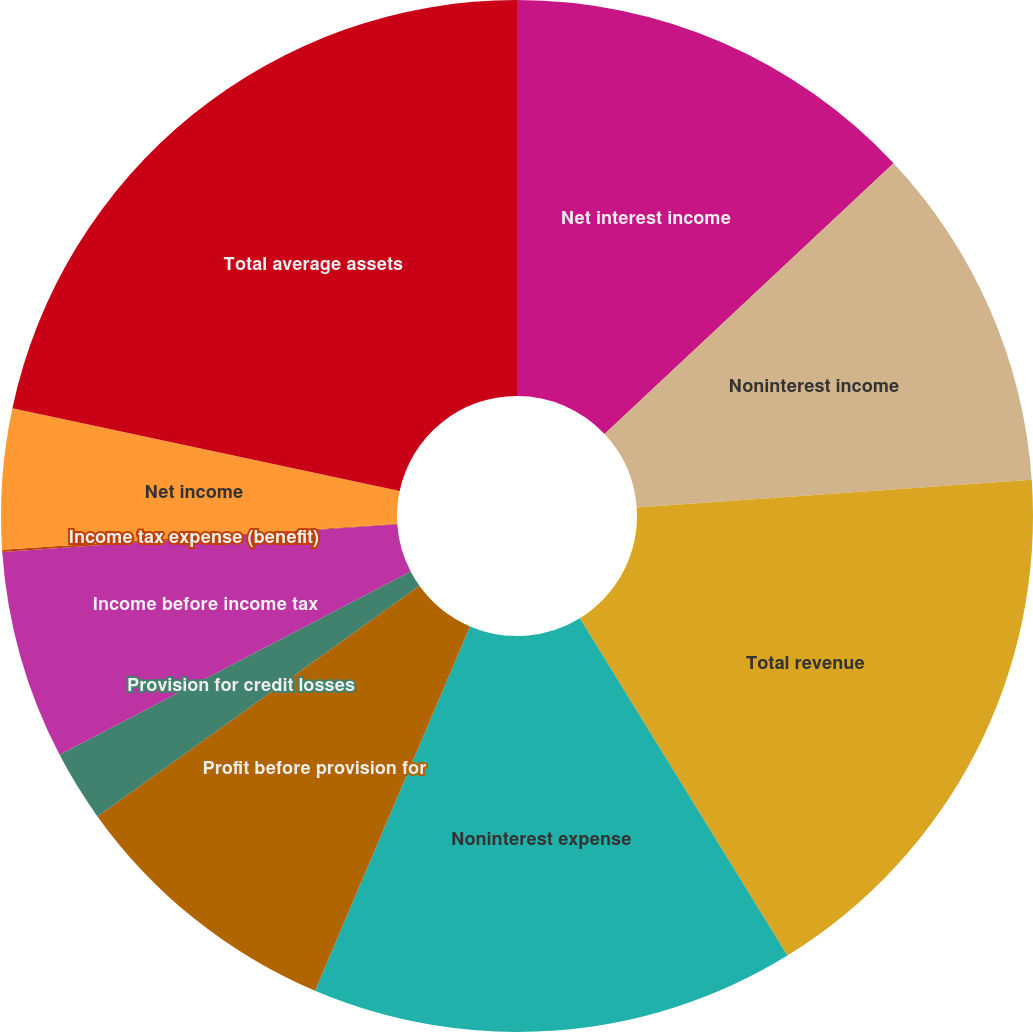Convert chart. <chart><loc_0><loc_0><loc_500><loc_500><pie_chart><fcel>Net interest income<fcel>Noninterest income<fcel>Total revenue<fcel>Noninterest expense<fcel>Profit before provision for<fcel>Provision for credit losses<fcel>Income before income tax<fcel>Income tax expense (benefit)<fcel>Net income<fcel>Total average assets<nl><fcel>13.02%<fcel>10.86%<fcel>17.34%<fcel>15.18%<fcel>8.71%<fcel>2.23%<fcel>6.55%<fcel>0.07%<fcel>4.39%<fcel>21.65%<nl></chart> 